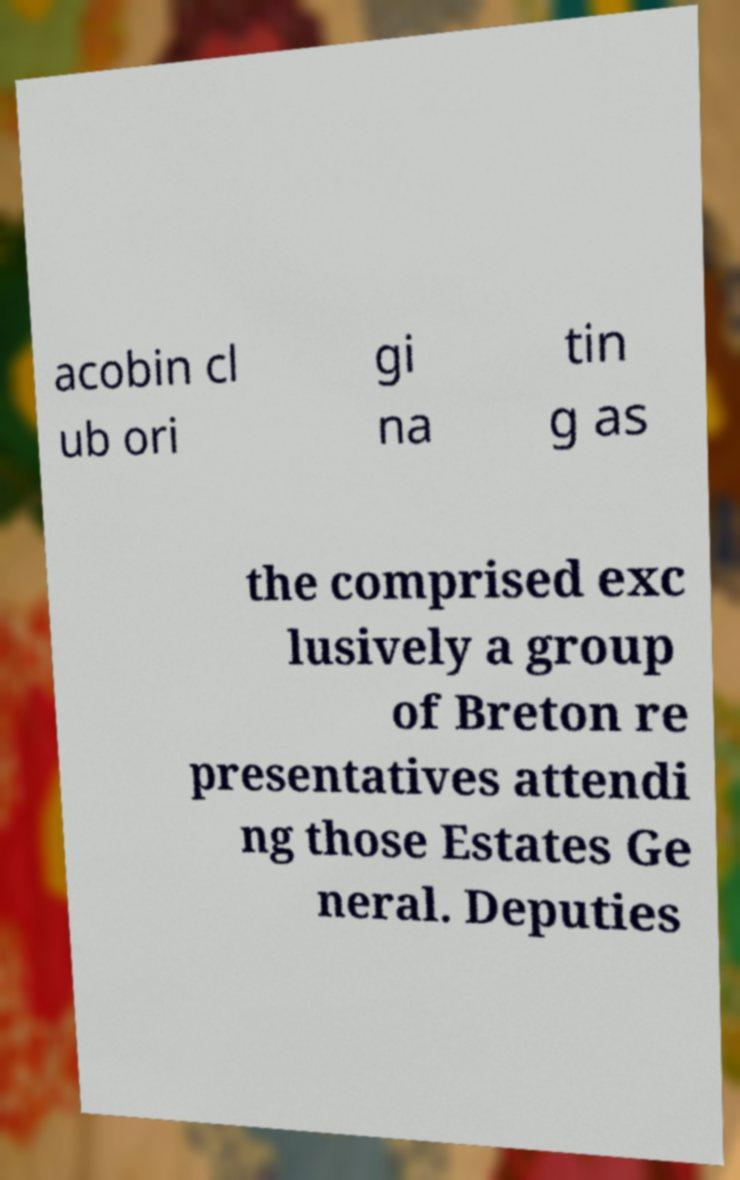Can you read and provide the text displayed in the image?This photo seems to have some interesting text. Can you extract and type it out for me? acobin cl ub ori gi na tin g as the comprised exc lusively a group of Breton re presentatives attendi ng those Estates Ge neral. Deputies 